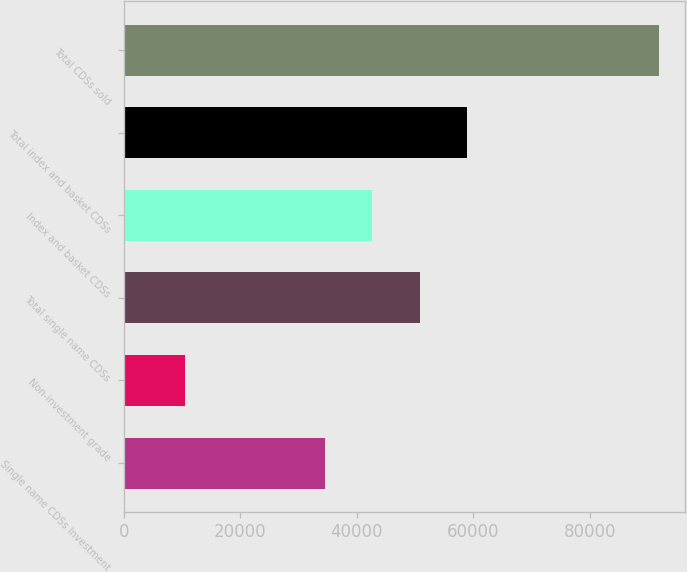Convert chart. <chart><loc_0><loc_0><loc_500><loc_500><bar_chart><fcel>Single name CDSs Investment<fcel>Non-investment grade<fcel>Total single name CDSs<fcel>Index and basket CDSs<fcel>Total index and basket CDSs<fcel>Total CDSs sold<nl><fcel>34529<fcel>10436<fcel>50798.6<fcel>42663.8<fcel>58933.4<fcel>91784<nl></chart> 